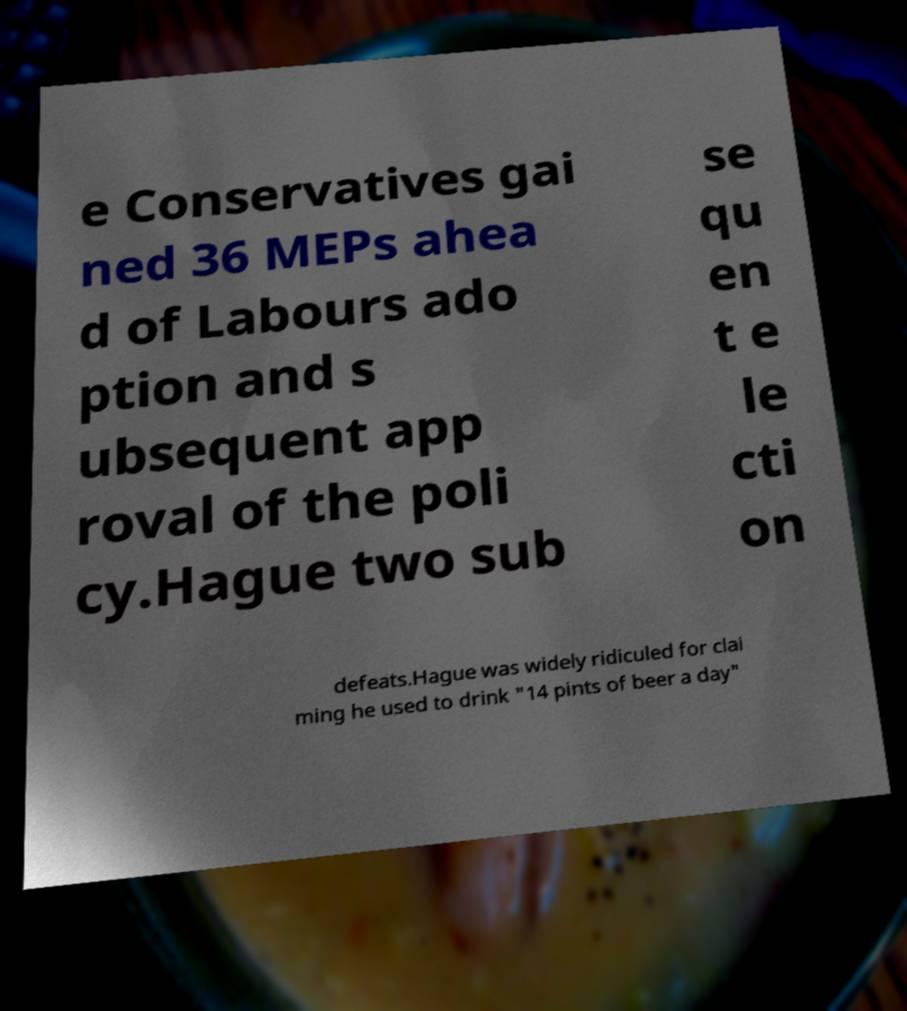Can you read and provide the text displayed in the image?This photo seems to have some interesting text. Can you extract and type it out for me? e Conservatives gai ned 36 MEPs ahea d of Labours ado ption and s ubsequent app roval of the poli cy.Hague two sub se qu en t e le cti on defeats.Hague was widely ridiculed for clai ming he used to drink "14 pints of beer a day" 